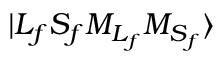<formula> <loc_0><loc_0><loc_500><loc_500>{ | { L } _ { f } { S } _ { f } { M } _ { { L } _ { f } } { M } _ { { S } _ { f } } \rangle }</formula> 